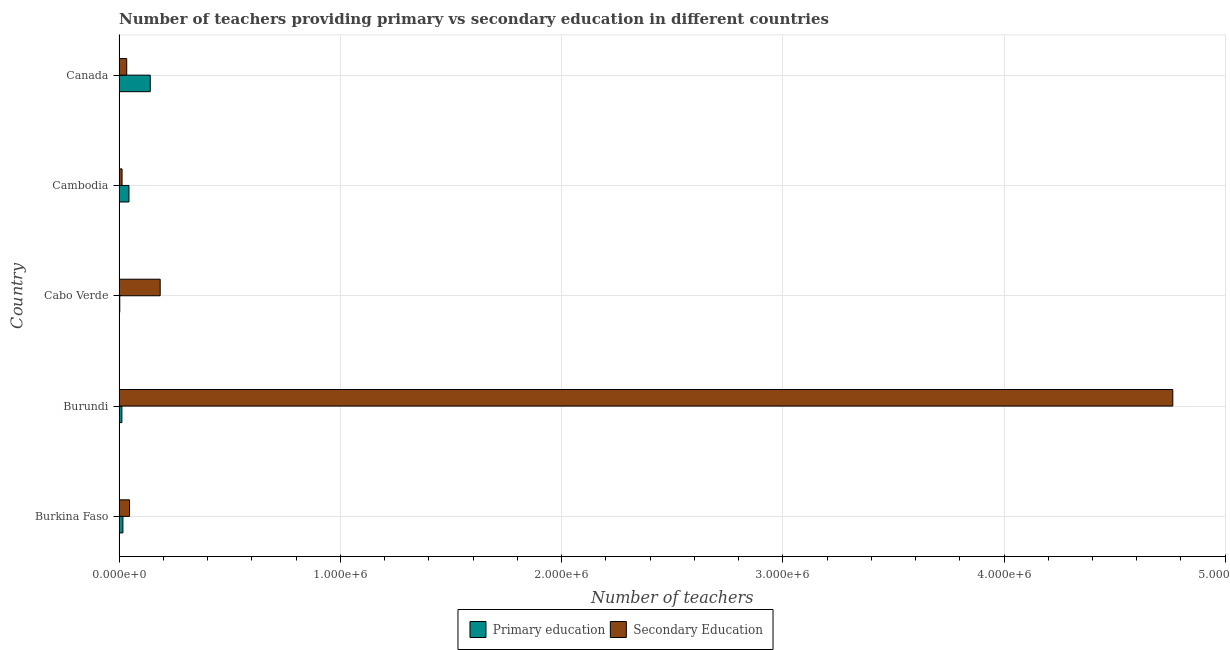How many different coloured bars are there?
Give a very brief answer. 2. How many groups of bars are there?
Your response must be concise. 5. Are the number of bars per tick equal to the number of legend labels?
Your answer should be compact. Yes. What is the label of the 3rd group of bars from the top?
Offer a very short reply. Cabo Verde. What is the number of secondary teachers in Canada?
Give a very brief answer. 3.47e+04. Across all countries, what is the maximum number of primary teachers?
Offer a terse response. 1.41e+05. Across all countries, what is the minimum number of secondary teachers?
Offer a very short reply. 1.36e+04. In which country was the number of primary teachers maximum?
Offer a very short reply. Canada. In which country was the number of secondary teachers minimum?
Make the answer very short. Cambodia. What is the total number of secondary teachers in the graph?
Keep it short and to the point. 5.04e+06. What is the difference between the number of secondary teachers in Burkina Faso and that in Cambodia?
Offer a terse response. 3.38e+04. What is the difference between the number of secondary teachers in Burundi and the number of primary teachers in Burkina Faso?
Ensure brevity in your answer.  4.75e+06. What is the average number of secondary teachers per country?
Offer a terse response. 1.01e+06. What is the difference between the number of primary teachers and number of secondary teachers in Burundi?
Offer a very short reply. -4.75e+06. What is the ratio of the number of secondary teachers in Burkina Faso to that in Burundi?
Your answer should be compact. 0.01. Is the number of primary teachers in Burkina Faso less than that in Burundi?
Your answer should be compact. No. Is the difference between the number of primary teachers in Cambodia and Canada greater than the difference between the number of secondary teachers in Cambodia and Canada?
Make the answer very short. No. What is the difference between the highest and the second highest number of secondary teachers?
Ensure brevity in your answer.  4.58e+06. What is the difference between the highest and the lowest number of primary teachers?
Make the answer very short. 1.38e+05. In how many countries, is the number of primary teachers greater than the average number of primary teachers taken over all countries?
Keep it short and to the point. 2. What does the 2nd bar from the bottom in Canada represents?
Give a very brief answer. Secondary Education. Are all the bars in the graph horizontal?
Your answer should be compact. Yes. What is the difference between two consecutive major ticks on the X-axis?
Keep it short and to the point. 1.00e+06. Does the graph contain any zero values?
Give a very brief answer. No. Where does the legend appear in the graph?
Give a very brief answer. Bottom center. How many legend labels are there?
Provide a succinct answer. 2. What is the title of the graph?
Give a very brief answer. Number of teachers providing primary vs secondary education in different countries. What is the label or title of the X-axis?
Your answer should be very brief. Number of teachers. What is the Number of teachers of Primary education in Burkina Faso?
Ensure brevity in your answer.  1.74e+04. What is the Number of teachers of Secondary Education in Burkina Faso?
Your answer should be very brief. 4.74e+04. What is the Number of teachers of Primary education in Burundi?
Offer a terse response. 1.27e+04. What is the Number of teachers in Secondary Education in Burundi?
Make the answer very short. 4.76e+06. What is the Number of teachers in Primary education in Cabo Verde?
Provide a short and direct response. 3190. What is the Number of teachers in Secondary Education in Cabo Verde?
Give a very brief answer. 1.86e+05. What is the Number of teachers in Primary education in Cambodia?
Offer a very short reply. 4.49e+04. What is the Number of teachers in Secondary Education in Cambodia?
Your answer should be compact. 1.36e+04. What is the Number of teachers in Primary education in Canada?
Offer a very short reply. 1.41e+05. What is the Number of teachers in Secondary Education in Canada?
Provide a short and direct response. 3.47e+04. Across all countries, what is the maximum Number of teachers in Primary education?
Provide a short and direct response. 1.41e+05. Across all countries, what is the maximum Number of teachers in Secondary Education?
Provide a short and direct response. 4.76e+06. Across all countries, what is the minimum Number of teachers of Primary education?
Make the answer very short. 3190. Across all countries, what is the minimum Number of teachers of Secondary Education?
Your answer should be compact. 1.36e+04. What is the total Number of teachers of Primary education in the graph?
Provide a short and direct response. 2.19e+05. What is the total Number of teachers of Secondary Education in the graph?
Your answer should be very brief. 5.04e+06. What is the difference between the Number of teachers of Primary education in Burkina Faso and that in Burundi?
Make the answer very short. 4704. What is the difference between the Number of teachers in Secondary Education in Burkina Faso and that in Burundi?
Make the answer very short. -4.72e+06. What is the difference between the Number of teachers of Primary education in Burkina Faso and that in Cabo Verde?
Provide a short and direct response. 1.42e+04. What is the difference between the Number of teachers in Secondary Education in Burkina Faso and that in Cabo Verde?
Provide a succinct answer. -1.39e+05. What is the difference between the Number of teachers in Primary education in Burkina Faso and that in Cambodia?
Provide a short and direct response. -2.74e+04. What is the difference between the Number of teachers of Secondary Education in Burkina Faso and that in Cambodia?
Your response must be concise. 3.38e+04. What is the difference between the Number of teachers of Primary education in Burkina Faso and that in Canada?
Ensure brevity in your answer.  -1.24e+05. What is the difference between the Number of teachers of Secondary Education in Burkina Faso and that in Canada?
Your answer should be compact. 1.27e+04. What is the difference between the Number of teachers in Primary education in Burundi and that in Cabo Verde?
Your answer should be compact. 9541. What is the difference between the Number of teachers of Secondary Education in Burundi and that in Cabo Verde?
Your answer should be very brief. 4.58e+06. What is the difference between the Number of teachers in Primary education in Burundi and that in Cambodia?
Offer a terse response. -3.21e+04. What is the difference between the Number of teachers of Secondary Education in Burundi and that in Cambodia?
Keep it short and to the point. 4.75e+06. What is the difference between the Number of teachers in Primary education in Burundi and that in Canada?
Provide a succinct answer. -1.28e+05. What is the difference between the Number of teachers in Secondary Education in Burundi and that in Canada?
Provide a succinct answer. 4.73e+06. What is the difference between the Number of teachers of Primary education in Cabo Verde and that in Cambodia?
Keep it short and to the point. -4.17e+04. What is the difference between the Number of teachers in Secondary Education in Cabo Verde and that in Cambodia?
Keep it short and to the point. 1.72e+05. What is the difference between the Number of teachers of Primary education in Cabo Verde and that in Canada?
Offer a very short reply. -1.38e+05. What is the difference between the Number of teachers of Secondary Education in Cabo Verde and that in Canada?
Keep it short and to the point. 1.51e+05. What is the difference between the Number of teachers in Primary education in Cambodia and that in Canada?
Your answer should be very brief. -9.62e+04. What is the difference between the Number of teachers of Secondary Education in Cambodia and that in Canada?
Provide a succinct answer. -2.11e+04. What is the difference between the Number of teachers in Primary education in Burkina Faso and the Number of teachers in Secondary Education in Burundi?
Ensure brevity in your answer.  -4.75e+06. What is the difference between the Number of teachers in Primary education in Burkina Faso and the Number of teachers in Secondary Education in Cabo Verde?
Give a very brief answer. -1.68e+05. What is the difference between the Number of teachers of Primary education in Burkina Faso and the Number of teachers of Secondary Education in Cambodia?
Provide a short and direct response. 3867. What is the difference between the Number of teachers in Primary education in Burkina Faso and the Number of teachers in Secondary Education in Canada?
Your answer should be very brief. -1.72e+04. What is the difference between the Number of teachers of Primary education in Burundi and the Number of teachers of Secondary Education in Cabo Verde?
Make the answer very short. -1.73e+05. What is the difference between the Number of teachers in Primary education in Burundi and the Number of teachers in Secondary Education in Cambodia?
Your answer should be compact. -837. What is the difference between the Number of teachers of Primary education in Burundi and the Number of teachers of Secondary Education in Canada?
Ensure brevity in your answer.  -2.19e+04. What is the difference between the Number of teachers of Primary education in Cabo Verde and the Number of teachers of Secondary Education in Cambodia?
Give a very brief answer. -1.04e+04. What is the difference between the Number of teachers of Primary education in Cabo Verde and the Number of teachers of Secondary Education in Canada?
Ensure brevity in your answer.  -3.15e+04. What is the difference between the Number of teachers of Primary education in Cambodia and the Number of teachers of Secondary Education in Canada?
Give a very brief answer. 1.02e+04. What is the average Number of teachers in Primary education per country?
Offer a very short reply. 4.39e+04. What is the average Number of teachers in Secondary Education per country?
Ensure brevity in your answer.  1.01e+06. What is the difference between the Number of teachers in Primary education and Number of teachers in Secondary Education in Burkina Faso?
Your answer should be compact. -3.00e+04. What is the difference between the Number of teachers of Primary education and Number of teachers of Secondary Education in Burundi?
Give a very brief answer. -4.75e+06. What is the difference between the Number of teachers in Primary education and Number of teachers in Secondary Education in Cabo Verde?
Provide a short and direct response. -1.83e+05. What is the difference between the Number of teachers in Primary education and Number of teachers in Secondary Education in Cambodia?
Offer a terse response. 3.13e+04. What is the difference between the Number of teachers in Primary education and Number of teachers in Secondary Education in Canada?
Your answer should be very brief. 1.06e+05. What is the ratio of the Number of teachers of Primary education in Burkina Faso to that in Burundi?
Ensure brevity in your answer.  1.37. What is the ratio of the Number of teachers of Primary education in Burkina Faso to that in Cabo Verde?
Your response must be concise. 5.47. What is the ratio of the Number of teachers in Secondary Education in Burkina Faso to that in Cabo Verde?
Provide a succinct answer. 0.25. What is the ratio of the Number of teachers of Primary education in Burkina Faso to that in Cambodia?
Ensure brevity in your answer.  0.39. What is the ratio of the Number of teachers in Secondary Education in Burkina Faso to that in Cambodia?
Provide a succinct answer. 3.49. What is the ratio of the Number of teachers in Primary education in Burkina Faso to that in Canada?
Your answer should be very brief. 0.12. What is the ratio of the Number of teachers in Secondary Education in Burkina Faso to that in Canada?
Ensure brevity in your answer.  1.37. What is the ratio of the Number of teachers in Primary education in Burundi to that in Cabo Verde?
Give a very brief answer. 3.99. What is the ratio of the Number of teachers of Secondary Education in Burundi to that in Cabo Verde?
Provide a succinct answer. 25.62. What is the ratio of the Number of teachers of Primary education in Burundi to that in Cambodia?
Make the answer very short. 0.28. What is the ratio of the Number of teachers in Secondary Education in Burundi to that in Cambodia?
Provide a short and direct response. 351.05. What is the ratio of the Number of teachers of Primary education in Burundi to that in Canada?
Provide a succinct answer. 0.09. What is the ratio of the Number of teachers in Secondary Education in Burundi to that in Canada?
Provide a short and direct response. 137.46. What is the ratio of the Number of teachers of Primary education in Cabo Verde to that in Cambodia?
Your answer should be very brief. 0.07. What is the ratio of the Number of teachers of Secondary Education in Cabo Verde to that in Cambodia?
Give a very brief answer. 13.7. What is the ratio of the Number of teachers of Primary education in Cabo Verde to that in Canada?
Ensure brevity in your answer.  0.02. What is the ratio of the Number of teachers in Secondary Education in Cabo Verde to that in Canada?
Provide a succinct answer. 5.37. What is the ratio of the Number of teachers in Primary education in Cambodia to that in Canada?
Offer a terse response. 0.32. What is the ratio of the Number of teachers in Secondary Education in Cambodia to that in Canada?
Give a very brief answer. 0.39. What is the difference between the highest and the second highest Number of teachers in Primary education?
Your response must be concise. 9.62e+04. What is the difference between the highest and the second highest Number of teachers in Secondary Education?
Keep it short and to the point. 4.58e+06. What is the difference between the highest and the lowest Number of teachers in Primary education?
Make the answer very short. 1.38e+05. What is the difference between the highest and the lowest Number of teachers of Secondary Education?
Provide a short and direct response. 4.75e+06. 